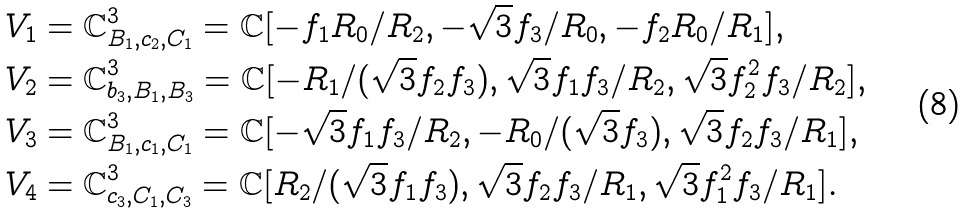Convert formula to latex. <formula><loc_0><loc_0><loc_500><loc_500>V _ { 1 } & = \mathbb { C } ^ { 3 } _ { B _ { 1 } , c _ { 2 } , C _ { 1 } } = \mathbb { C } [ - f _ { 1 } R _ { 0 } / R _ { 2 } , - \sqrt { 3 } f _ { 3 } / R _ { 0 } , - f _ { 2 } R _ { 0 } / R _ { 1 } ] , \\ V _ { 2 } & = \mathbb { C } ^ { 3 } _ { b _ { 3 } , B _ { 1 } , B _ { 3 } } = \mathbb { C } [ - R _ { 1 } / ( \sqrt { 3 } f _ { 2 } f _ { 3 } ) , \sqrt { 3 } f _ { 1 } f _ { 3 } / R _ { 2 } , \sqrt { 3 } f _ { 2 } ^ { 2 } f _ { 3 } / R _ { 2 } ] , \\ V _ { 3 } & = \mathbb { C } ^ { 3 } _ { B _ { 1 } , c _ { 1 } , C _ { 1 } } = \mathbb { C } [ - \sqrt { 3 } f _ { 1 } f _ { 3 } / R _ { 2 } , - R _ { 0 } / ( \sqrt { 3 } f _ { 3 } ) , \sqrt { 3 } f _ { 2 } f _ { 3 } / R _ { 1 } ] , \\ V _ { 4 } & = \mathbb { C } ^ { 3 } _ { c _ { 3 } , C _ { 1 } , C _ { 3 } } = \mathbb { C } [ R _ { 2 } / ( \sqrt { 3 } f _ { 1 } f _ { 3 } ) , \sqrt { 3 } f _ { 2 } f _ { 3 } / R _ { 1 } , \sqrt { 3 } f _ { 1 } ^ { 2 } f _ { 3 } / R _ { 1 } ] .</formula> 